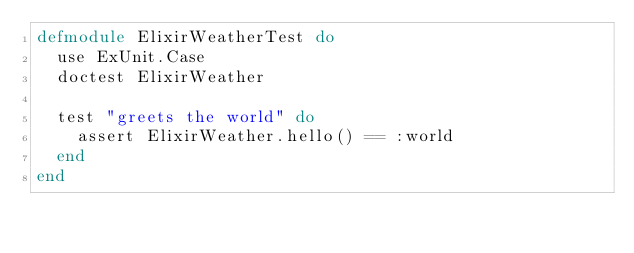Convert code to text. <code><loc_0><loc_0><loc_500><loc_500><_Elixir_>defmodule ElixirWeatherTest do
  use ExUnit.Case
  doctest ElixirWeather

  test "greets the world" do
    assert ElixirWeather.hello() == :world
  end
end
</code> 